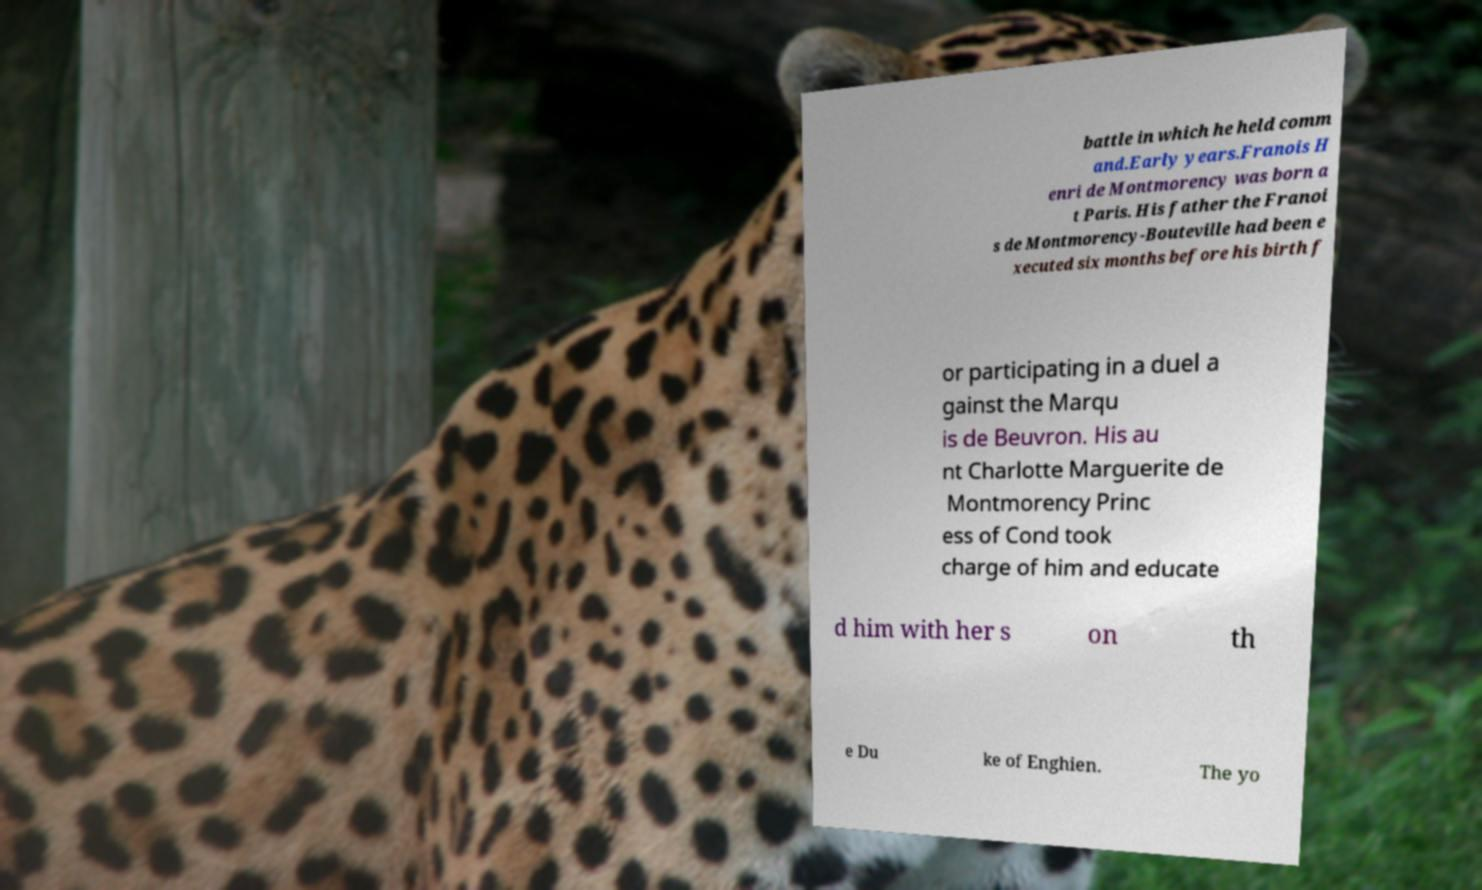Please read and relay the text visible in this image. What does it say? battle in which he held comm and.Early years.Franois H enri de Montmorency was born a t Paris. His father the Franoi s de Montmorency-Bouteville had been e xecuted six months before his birth f or participating in a duel a gainst the Marqu is de Beuvron. His au nt Charlotte Marguerite de Montmorency Princ ess of Cond took charge of him and educate d him with her s on th e Du ke of Enghien. The yo 